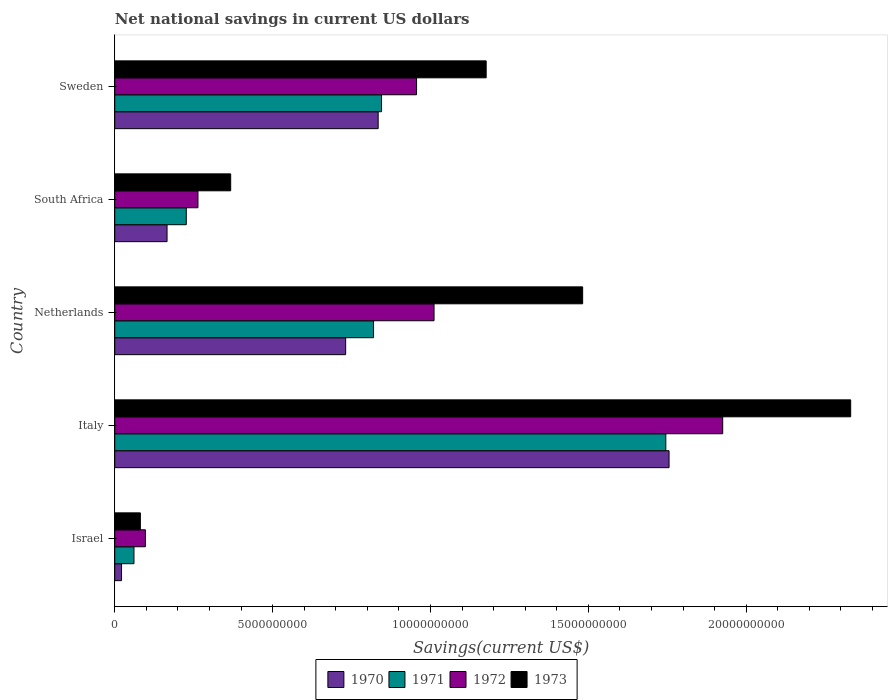How many different coloured bars are there?
Offer a terse response. 4. Are the number of bars on each tick of the Y-axis equal?
Provide a succinct answer. Yes. How many bars are there on the 5th tick from the top?
Ensure brevity in your answer.  4. How many bars are there on the 4th tick from the bottom?
Give a very brief answer. 4. What is the label of the 4th group of bars from the top?
Provide a short and direct response. Italy. What is the net national savings in 1970 in Italy?
Ensure brevity in your answer.  1.76e+1. Across all countries, what is the maximum net national savings in 1971?
Your answer should be compact. 1.75e+1. Across all countries, what is the minimum net national savings in 1970?
Ensure brevity in your answer.  2.15e+08. In which country was the net national savings in 1970 maximum?
Ensure brevity in your answer.  Italy. What is the total net national savings in 1970 in the graph?
Your response must be concise. 3.51e+1. What is the difference between the net national savings in 1973 in Netherlands and that in South Africa?
Your answer should be very brief. 1.11e+1. What is the difference between the net national savings in 1972 in Italy and the net national savings in 1973 in South Africa?
Offer a very short reply. 1.56e+1. What is the average net national savings in 1972 per country?
Your response must be concise. 8.51e+09. What is the difference between the net national savings in 1970 and net national savings in 1972 in Netherlands?
Offer a very short reply. -2.80e+09. What is the ratio of the net national savings in 1972 in Israel to that in Netherlands?
Make the answer very short. 0.1. Is the difference between the net national savings in 1970 in Italy and Sweden greater than the difference between the net national savings in 1972 in Italy and Sweden?
Provide a short and direct response. No. What is the difference between the highest and the second highest net national savings in 1972?
Keep it short and to the point. 9.14e+09. What is the difference between the highest and the lowest net national savings in 1972?
Give a very brief answer. 1.83e+1. In how many countries, is the net national savings in 1970 greater than the average net national savings in 1970 taken over all countries?
Provide a short and direct response. 3. Is the sum of the net national savings in 1971 in Israel and South Africa greater than the maximum net national savings in 1970 across all countries?
Offer a terse response. No. Is it the case that in every country, the sum of the net national savings in 1972 and net national savings in 1970 is greater than the sum of net national savings in 1973 and net national savings in 1971?
Your answer should be compact. No. What does the 2nd bar from the top in Italy represents?
Offer a very short reply. 1972. What is the difference between two consecutive major ticks on the X-axis?
Ensure brevity in your answer.  5.00e+09. Are the values on the major ticks of X-axis written in scientific E-notation?
Your response must be concise. No. Does the graph contain any zero values?
Your answer should be compact. No. Does the graph contain grids?
Ensure brevity in your answer.  No. Where does the legend appear in the graph?
Offer a terse response. Bottom center. What is the title of the graph?
Provide a succinct answer. Net national savings in current US dollars. What is the label or title of the X-axis?
Your response must be concise. Savings(current US$). What is the label or title of the Y-axis?
Make the answer very short. Country. What is the Savings(current US$) in 1970 in Israel?
Your answer should be compact. 2.15e+08. What is the Savings(current US$) in 1971 in Israel?
Ensure brevity in your answer.  6.09e+08. What is the Savings(current US$) in 1972 in Israel?
Your response must be concise. 9.71e+08. What is the Savings(current US$) in 1973 in Israel?
Your response must be concise. 8.11e+08. What is the Savings(current US$) of 1970 in Italy?
Offer a very short reply. 1.76e+1. What is the Savings(current US$) in 1971 in Italy?
Provide a succinct answer. 1.75e+1. What is the Savings(current US$) in 1972 in Italy?
Your answer should be compact. 1.93e+1. What is the Savings(current US$) in 1973 in Italy?
Give a very brief answer. 2.33e+1. What is the Savings(current US$) of 1970 in Netherlands?
Ensure brevity in your answer.  7.31e+09. What is the Savings(current US$) of 1971 in Netherlands?
Provide a succinct answer. 8.20e+09. What is the Savings(current US$) of 1972 in Netherlands?
Give a very brief answer. 1.01e+1. What is the Savings(current US$) in 1973 in Netherlands?
Make the answer very short. 1.48e+1. What is the Savings(current US$) in 1970 in South Africa?
Ensure brevity in your answer.  1.66e+09. What is the Savings(current US$) in 1971 in South Africa?
Offer a very short reply. 2.27e+09. What is the Savings(current US$) in 1972 in South Africa?
Give a very brief answer. 2.64e+09. What is the Savings(current US$) of 1973 in South Africa?
Offer a very short reply. 3.67e+09. What is the Savings(current US$) of 1970 in Sweden?
Offer a terse response. 8.34e+09. What is the Savings(current US$) in 1971 in Sweden?
Offer a very short reply. 8.45e+09. What is the Savings(current US$) of 1972 in Sweden?
Ensure brevity in your answer.  9.56e+09. What is the Savings(current US$) in 1973 in Sweden?
Give a very brief answer. 1.18e+1. Across all countries, what is the maximum Savings(current US$) in 1970?
Your response must be concise. 1.76e+1. Across all countries, what is the maximum Savings(current US$) in 1971?
Ensure brevity in your answer.  1.75e+1. Across all countries, what is the maximum Savings(current US$) in 1972?
Your answer should be compact. 1.93e+1. Across all countries, what is the maximum Savings(current US$) of 1973?
Ensure brevity in your answer.  2.33e+1. Across all countries, what is the minimum Savings(current US$) in 1970?
Offer a very short reply. 2.15e+08. Across all countries, what is the minimum Savings(current US$) of 1971?
Your answer should be compact. 6.09e+08. Across all countries, what is the minimum Savings(current US$) in 1972?
Give a very brief answer. 9.71e+08. Across all countries, what is the minimum Savings(current US$) of 1973?
Your answer should be very brief. 8.11e+08. What is the total Savings(current US$) in 1970 in the graph?
Your answer should be very brief. 3.51e+1. What is the total Savings(current US$) in 1971 in the graph?
Ensure brevity in your answer.  3.70e+1. What is the total Savings(current US$) of 1972 in the graph?
Keep it short and to the point. 4.25e+1. What is the total Savings(current US$) in 1973 in the graph?
Give a very brief answer. 5.44e+1. What is the difference between the Savings(current US$) in 1970 in Israel and that in Italy?
Offer a terse response. -1.73e+1. What is the difference between the Savings(current US$) in 1971 in Israel and that in Italy?
Your response must be concise. -1.68e+1. What is the difference between the Savings(current US$) in 1972 in Israel and that in Italy?
Keep it short and to the point. -1.83e+1. What is the difference between the Savings(current US$) of 1973 in Israel and that in Italy?
Give a very brief answer. -2.25e+1. What is the difference between the Savings(current US$) of 1970 in Israel and that in Netherlands?
Ensure brevity in your answer.  -7.10e+09. What is the difference between the Savings(current US$) in 1971 in Israel and that in Netherlands?
Ensure brevity in your answer.  -7.59e+09. What is the difference between the Savings(current US$) of 1972 in Israel and that in Netherlands?
Give a very brief answer. -9.14e+09. What is the difference between the Savings(current US$) of 1973 in Israel and that in Netherlands?
Keep it short and to the point. -1.40e+1. What is the difference between the Savings(current US$) of 1970 in Israel and that in South Africa?
Offer a terse response. -1.44e+09. What is the difference between the Savings(current US$) in 1971 in Israel and that in South Africa?
Offer a very short reply. -1.66e+09. What is the difference between the Savings(current US$) in 1972 in Israel and that in South Africa?
Your answer should be very brief. -1.66e+09. What is the difference between the Savings(current US$) of 1973 in Israel and that in South Africa?
Make the answer very short. -2.86e+09. What is the difference between the Savings(current US$) of 1970 in Israel and that in Sweden?
Offer a terse response. -8.13e+09. What is the difference between the Savings(current US$) of 1971 in Israel and that in Sweden?
Keep it short and to the point. -7.84e+09. What is the difference between the Savings(current US$) in 1972 in Israel and that in Sweden?
Offer a terse response. -8.59e+09. What is the difference between the Savings(current US$) of 1973 in Israel and that in Sweden?
Provide a succinct answer. -1.10e+1. What is the difference between the Savings(current US$) in 1970 in Italy and that in Netherlands?
Offer a very short reply. 1.02e+1. What is the difference between the Savings(current US$) of 1971 in Italy and that in Netherlands?
Offer a terse response. 9.26e+09. What is the difference between the Savings(current US$) in 1972 in Italy and that in Netherlands?
Your answer should be compact. 9.14e+09. What is the difference between the Savings(current US$) of 1973 in Italy and that in Netherlands?
Your answer should be compact. 8.49e+09. What is the difference between the Savings(current US$) of 1970 in Italy and that in South Africa?
Your response must be concise. 1.59e+1. What is the difference between the Savings(current US$) of 1971 in Italy and that in South Africa?
Keep it short and to the point. 1.52e+1. What is the difference between the Savings(current US$) of 1972 in Italy and that in South Africa?
Offer a terse response. 1.66e+1. What is the difference between the Savings(current US$) of 1973 in Italy and that in South Africa?
Offer a terse response. 1.96e+1. What is the difference between the Savings(current US$) in 1970 in Italy and that in Sweden?
Make the answer very short. 9.21e+09. What is the difference between the Savings(current US$) in 1971 in Italy and that in Sweden?
Ensure brevity in your answer.  9.00e+09. What is the difference between the Savings(current US$) in 1972 in Italy and that in Sweden?
Keep it short and to the point. 9.70e+09. What is the difference between the Savings(current US$) of 1973 in Italy and that in Sweden?
Your answer should be very brief. 1.15e+1. What is the difference between the Savings(current US$) of 1970 in Netherlands and that in South Africa?
Give a very brief answer. 5.66e+09. What is the difference between the Savings(current US$) in 1971 in Netherlands and that in South Africa?
Offer a terse response. 5.93e+09. What is the difference between the Savings(current US$) in 1972 in Netherlands and that in South Africa?
Provide a short and direct response. 7.48e+09. What is the difference between the Savings(current US$) of 1973 in Netherlands and that in South Africa?
Provide a short and direct response. 1.11e+1. What is the difference between the Savings(current US$) of 1970 in Netherlands and that in Sweden?
Provide a succinct answer. -1.03e+09. What is the difference between the Savings(current US$) of 1971 in Netherlands and that in Sweden?
Ensure brevity in your answer.  -2.53e+08. What is the difference between the Savings(current US$) of 1972 in Netherlands and that in Sweden?
Your answer should be very brief. 5.54e+08. What is the difference between the Savings(current US$) of 1973 in Netherlands and that in Sweden?
Make the answer very short. 3.06e+09. What is the difference between the Savings(current US$) in 1970 in South Africa and that in Sweden?
Provide a short and direct response. -6.69e+09. What is the difference between the Savings(current US$) in 1971 in South Africa and that in Sweden?
Your answer should be very brief. -6.18e+09. What is the difference between the Savings(current US$) of 1972 in South Africa and that in Sweden?
Your answer should be very brief. -6.92e+09. What is the difference between the Savings(current US$) in 1973 in South Africa and that in Sweden?
Ensure brevity in your answer.  -8.09e+09. What is the difference between the Savings(current US$) of 1970 in Israel and the Savings(current US$) of 1971 in Italy?
Offer a terse response. -1.72e+1. What is the difference between the Savings(current US$) of 1970 in Israel and the Savings(current US$) of 1972 in Italy?
Provide a short and direct response. -1.90e+1. What is the difference between the Savings(current US$) of 1970 in Israel and the Savings(current US$) of 1973 in Italy?
Make the answer very short. -2.31e+1. What is the difference between the Savings(current US$) in 1971 in Israel and the Savings(current US$) in 1972 in Italy?
Make the answer very short. -1.86e+1. What is the difference between the Savings(current US$) in 1971 in Israel and the Savings(current US$) in 1973 in Italy?
Make the answer very short. -2.27e+1. What is the difference between the Savings(current US$) in 1972 in Israel and the Savings(current US$) in 1973 in Italy?
Your answer should be very brief. -2.23e+1. What is the difference between the Savings(current US$) of 1970 in Israel and the Savings(current US$) of 1971 in Netherlands?
Your response must be concise. -7.98e+09. What is the difference between the Savings(current US$) in 1970 in Israel and the Savings(current US$) in 1972 in Netherlands?
Provide a short and direct response. -9.90e+09. What is the difference between the Savings(current US$) in 1970 in Israel and the Savings(current US$) in 1973 in Netherlands?
Offer a very short reply. -1.46e+1. What is the difference between the Savings(current US$) of 1971 in Israel and the Savings(current US$) of 1972 in Netherlands?
Provide a succinct answer. -9.50e+09. What is the difference between the Savings(current US$) in 1971 in Israel and the Savings(current US$) in 1973 in Netherlands?
Provide a succinct answer. -1.42e+1. What is the difference between the Savings(current US$) in 1972 in Israel and the Savings(current US$) in 1973 in Netherlands?
Your answer should be compact. -1.38e+1. What is the difference between the Savings(current US$) of 1970 in Israel and the Savings(current US$) of 1971 in South Africa?
Keep it short and to the point. -2.05e+09. What is the difference between the Savings(current US$) of 1970 in Israel and the Savings(current US$) of 1972 in South Africa?
Your response must be concise. -2.42e+09. What is the difference between the Savings(current US$) of 1970 in Israel and the Savings(current US$) of 1973 in South Africa?
Your answer should be very brief. -3.46e+09. What is the difference between the Savings(current US$) of 1971 in Israel and the Savings(current US$) of 1972 in South Africa?
Ensure brevity in your answer.  -2.03e+09. What is the difference between the Savings(current US$) of 1971 in Israel and the Savings(current US$) of 1973 in South Africa?
Make the answer very short. -3.06e+09. What is the difference between the Savings(current US$) of 1972 in Israel and the Savings(current US$) of 1973 in South Africa?
Offer a terse response. -2.70e+09. What is the difference between the Savings(current US$) in 1970 in Israel and the Savings(current US$) in 1971 in Sweden?
Offer a terse response. -8.23e+09. What is the difference between the Savings(current US$) in 1970 in Israel and the Savings(current US$) in 1972 in Sweden?
Your response must be concise. -9.34e+09. What is the difference between the Savings(current US$) of 1970 in Israel and the Savings(current US$) of 1973 in Sweden?
Give a very brief answer. -1.15e+1. What is the difference between the Savings(current US$) of 1971 in Israel and the Savings(current US$) of 1972 in Sweden?
Provide a succinct answer. -8.95e+09. What is the difference between the Savings(current US$) of 1971 in Israel and the Savings(current US$) of 1973 in Sweden?
Offer a very short reply. -1.12e+1. What is the difference between the Savings(current US$) in 1972 in Israel and the Savings(current US$) in 1973 in Sweden?
Keep it short and to the point. -1.08e+1. What is the difference between the Savings(current US$) in 1970 in Italy and the Savings(current US$) in 1971 in Netherlands?
Offer a very short reply. 9.36e+09. What is the difference between the Savings(current US$) in 1970 in Italy and the Savings(current US$) in 1972 in Netherlands?
Ensure brevity in your answer.  7.44e+09. What is the difference between the Savings(current US$) in 1970 in Italy and the Savings(current US$) in 1973 in Netherlands?
Your response must be concise. 2.74e+09. What is the difference between the Savings(current US$) in 1971 in Italy and the Savings(current US$) in 1972 in Netherlands?
Provide a short and direct response. 7.34e+09. What is the difference between the Savings(current US$) in 1971 in Italy and the Savings(current US$) in 1973 in Netherlands?
Offer a terse response. 2.63e+09. What is the difference between the Savings(current US$) of 1972 in Italy and the Savings(current US$) of 1973 in Netherlands?
Provide a short and direct response. 4.44e+09. What is the difference between the Savings(current US$) in 1970 in Italy and the Savings(current US$) in 1971 in South Africa?
Keep it short and to the point. 1.53e+1. What is the difference between the Savings(current US$) of 1970 in Italy and the Savings(current US$) of 1972 in South Africa?
Give a very brief answer. 1.49e+1. What is the difference between the Savings(current US$) in 1970 in Italy and the Savings(current US$) in 1973 in South Africa?
Make the answer very short. 1.39e+1. What is the difference between the Savings(current US$) in 1971 in Italy and the Savings(current US$) in 1972 in South Africa?
Ensure brevity in your answer.  1.48e+1. What is the difference between the Savings(current US$) in 1971 in Italy and the Savings(current US$) in 1973 in South Africa?
Offer a very short reply. 1.38e+1. What is the difference between the Savings(current US$) of 1972 in Italy and the Savings(current US$) of 1973 in South Africa?
Your answer should be very brief. 1.56e+1. What is the difference between the Savings(current US$) of 1970 in Italy and the Savings(current US$) of 1971 in Sweden?
Ensure brevity in your answer.  9.11e+09. What is the difference between the Savings(current US$) of 1970 in Italy and the Savings(current US$) of 1972 in Sweden?
Offer a very short reply. 8.00e+09. What is the difference between the Savings(current US$) of 1970 in Italy and the Savings(current US$) of 1973 in Sweden?
Give a very brief answer. 5.79e+09. What is the difference between the Savings(current US$) of 1971 in Italy and the Savings(current US$) of 1972 in Sweden?
Give a very brief answer. 7.89e+09. What is the difference between the Savings(current US$) in 1971 in Italy and the Savings(current US$) in 1973 in Sweden?
Your response must be concise. 5.69e+09. What is the difference between the Savings(current US$) of 1972 in Italy and the Savings(current US$) of 1973 in Sweden?
Offer a very short reply. 7.49e+09. What is the difference between the Savings(current US$) of 1970 in Netherlands and the Savings(current US$) of 1971 in South Africa?
Your response must be concise. 5.05e+09. What is the difference between the Savings(current US$) of 1970 in Netherlands and the Savings(current US$) of 1972 in South Africa?
Offer a terse response. 4.68e+09. What is the difference between the Savings(current US$) of 1970 in Netherlands and the Savings(current US$) of 1973 in South Africa?
Your response must be concise. 3.64e+09. What is the difference between the Savings(current US$) of 1971 in Netherlands and the Savings(current US$) of 1972 in South Africa?
Your answer should be very brief. 5.56e+09. What is the difference between the Savings(current US$) of 1971 in Netherlands and the Savings(current US$) of 1973 in South Africa?
Ensure brevity in your answer.  4.52e+09. What is the difference between the Savings(current US$) in 1972 in Netherlands and the Savings(current US$) in 1973 in South Africa?
Offer a terse response. 6.44e+09. What is the difference between the Savings(current US$) of 1970 in Netherlands and the Savings(current US$) of 1971 in Sweden?
Offer a very short reply. -1.14e+09. What is the difference between the Savings(current US$) of 1970 in Netherlands and the Savings(current US$) of 1972 in Sweden?
Make the answer very short. -2.25e+09. What is the difference between the Savings(current US$) in 1970 in Netherlands and the Savings(current US$) in 1973 in Sweden?
Your response must be concise. -4.45e+09. What is the difference between the Savings(current US$) in 1971 in Netherlands and the Savings(current US$) in 1972 in Sweden?
Ensure brevity in your answer.  -1.36e+09. What is the difference between the Savings(current US$) of 1971 in Netherlands and the Savings(current US$) of 1973 in Sweden?
Your answer should be compact. -3.57e+09. What is the difference between the Savings(current US$) of 1972 in Netherlands and the Savings(current US$) of 1973 in Sweden?
Your response must be concise. -1.65e+09. What is the difference between the Savings(current US$) of 1970 in South Africa and the Savings(current US$) of 1971 in Sweden?
Your answer should be compact. -6.79e+09. What is the difference between the Savings(current US$) in 1970 in South Africa and the Savings(current US$) in 1972 in Sweden?
Make the answer very short. -7.90e+09. What is the difference between the Savings(current US$) in 1970 in South Africa and the Savings(current US$) in 1973 in Sweden?
Provide a short and direct response. -1.01e+1. What is the difference between the Savings(current US$) of 1971 in South Africa and the Savings(current US$) of 1972 in Sweden?
Give a very brief answer. -7.29e+09. What is the difference between the Savings(current US$) in 1971 in South Africa and the Savings(current US$) in 1973 in Sweden?
Ensure brevity in your answer.  -9.50e+09. What is the difference between the Savings(current US$) in 1972 in South Africa and the Savings(current US$) in 1973 in Sweden?
Your response must be concise. -9.13e+09. What is the average Savings(current US$) of 1970 per country?
Your response must be concise. 7.02e+09. What is the average Savings(current US$) of 1971 per country?
Provide a short and direct response. 7.39e+09. What is the average Savings(current US$) in 1972 per country?
Your answer should be very brief. 8.51e+09. What is the average Savings(current US$) in 1973 per country?
Ensure brevity in your answer.  1.09e+1. What is the difference between the Savings(current US$) in 1970 and Savings(current US$) in 1971 in Israel?
Offer a terse response. -3.94e+08. What is the difference between the Savings(current US$) of 1970 and Savings(current US$) of 1972 in Israel?
Offer a terse response. -7.56e+08. What is the difference between the Savings(current US$) in 1970 and Savings(current US$) in 1973 in Israel?
Your answer should be very brief. -5.96e+08. What is the difference between the Savings(current US$) in 1971 and Savings(current US$) in 1972 in Israel?
Make the answer very short. -3.62e+08. What is the difference between the Savings(current US$) in 1971 and Savings(current US$) in 1973 in Israel?
Make the answer very short. -2.02e+08. What is the difference between the Savings(current US$) in 1972 and Savings(current US$) in 1973 in Israel?
Offer a very short reply. 1.60e+08. What is the difference between the Savings(current US$) of 1970 and Savings(current US$) of 1971 in Italy?
Your answer should be compact. 1.03e+08. What is the difference between the Savings(current US$) of 1970 and Savings(current US$) of 1972 in Italy?
Your answer should be compact. -1.70e+09. What is the difference between the Savings(current US$) in 1970 and Savings(current US$) in 1973 in Italy?
Your response must be concise. -5.75e+09. What is the difference between the Savings(current US$) in 1971 and Savings(current US$) in 1972 in Italy?
Your response must be concise. -1.80e+09. What is the difference between the Savings(current US$) of 1971 and Savings(current US$) of 1973 in Italy?
Your answer should be very brief. -5.86e+09. What is the difference between the Savings(current US$) in 1972 and Savings(current US$) in 1973 in Italy?
Give a very brief answer. -4.05e+09. What is the difference between the Savings(current US$) in 1970 and Savings(current US$) in 1971 in Netherlands?
Offer a very short reply. -8.83e+08. What is the difference between the Savings(current US$) of 1970 and Savings(current US$) of 1972 in Netherlands?
Your response must be concise. -2.80e+09. What is the difference between the Savings(current US$) in 1970 and Savings(current US$) in 1973 in Netherlands?
Your answer should be very brief. -7.51e+09. What is the difference between the Savings(current US$) of 1971 and Savings(current US$) of 1972 in Netherlands?
Make the answer very short. -1.92e+09. What is the difference between the Savings(current US$) of 1971 and Savings(current US$) of 1973 in Netherlands?
Provide a succinct answer. -6.62e+09. What is the difference between the Savings(current US$) of 1972 and Savings(current US$) of 1973 in Netherlands?
Your answer should be compact. -4.71e+09. What is the difference between the Savings(current US$) in 1970 and Savings(current US$) in 1971 in South Africa?
Your answer should be very brief. -6.09e+08. What is the difference between the Savings(current US$) in 1970 and Savings(current US$) in 1972 in South Africa?
Your answer should be very brief. -9.79e+08. What is the difference between the Savings(current US$) in 1970 and Savings(current US$) in 1973 in South Africa?
Offer a terse response. -2.02e+09. What is the difference between the Savings(current US$) of 1971 and Savings(current US$) of 1972 in South Africa?
Provide a short and direct response. -3.70e+08. What is the difference between the Savings(current US$) of 1971 and Savings(current US$) of 1973 in South Africa?
Keep it short and to the point. -1.41e+09. What is the difference between the Savings(current US$) of 1972 and Savings(current US$) of 1973 in South Africa?
Your response must be concise. -1.04e+09. What is the difference between the Savings(current US$) of 1970 and Savings(current US$) of 1971 in Sweden?
Offer a very short reply. -1.07e+08. What is the difference between the Savings(current US$) in 1970 and Savings(current US$) in 1972 in Sweden?
Provide a short and direct response. -1.22e+09. What is the difference between the Savings(current US$) in 1970 and Savings(current US$) in 1973 in Sweden?
Provide a succinct answer. -3.42e+09. What is the difference between the Savings(current US$) of 1971 and Savings(current US$) of 1972 in Sweden?
Provide a succinct answer. -1.11e+09. What is the difference between the Savings(current US$) of 1971 and Savings(current US$) of 1973 in Sweden?
Provide a succinct answer. -3.31e+09. What is the difference between the Savings(current US$) of 1972 and Savings(current US$) of 1973 in Sweden?
Offer a very short reply. -2.20e+09. What is the ratio of the Savings(current US$) in 1970 in Israel to that in Italy?
Make the answer very short. 0.01. What is the ratio of the Savings(current US$) in 1971 in Israel to that in Italy?
Keep it short and to the point. 0.03. What is the ratio of the Savings(current US$) in 1972 in Israel to that in Italy?
Offer a terse response. 0.05. What is the ratio of the Savings(current US$) of 1973 in Israel to that in Italy?
Offer a terse response. 0.03. What is the ratio of the Savings(current US$) in 1970 in Israel to that in Netherlands?
Make the answer very short. 0.03. What is the ratio of the Savings(current US$) of 1971 in Israel to that in Netherlands?
Provide a succinct answer. 0.07. What is the ratio of the Savings(current US$) of 1972 in Israel to that in Netherlands?
Your answer should be compact. 0.1. What is the ratio of the Savings(current US$) in 1973 in Israel to that in Netherlands?
Offer a very short reply. 0.05. What is the ratio of the Savings(current US$) in 1970 in Israel to that in South Africa?
Provide a succinct answer. 0.13. What is the ratio of the Savings(current US$) of 1971 in Israel to that in South Africa?
Your answer should be compact. 0.27. What is the ratio of the Savings(current US$) in 1972 in Israel to that in South Africa?
Give a very brief answer. 0.37. What is the ratio of the Savings(current US$) in 1973 in Israel to that in South Africa?
Offer a terse response. 0.22. What is the ratio of the Savings(current US$) of 1970 in Israel to that in Sweden?
Your answer should be compact. 0.03. What is the ratio of the Savings(current US$) of 1971 in Israel to that in Sweden?
Make the answer very short. 0.07. What is the ratio of the Savings(current US$) of 1972 in Israel to that in Sweden?
Provide a short and direct response. 0.1. What is the ratio of the Savings(current US$) in 1973 in Israel to that in Sweden?
Your response must be concise. 0.07. What is the ratio of the Savings(current US$) in 1970 in Italy to that in Netherlands?
Offer a very short reply. 2.4. What is the ratio of the Savings(current US$) of 1971 in Italy to that in Netherlands?
Ensure brevity in your answer.  2.13. What is the ratio of the Savings(current US$) in 1972 in Italy to that in Netherlands?
Offer a terse response. 1.9. What is the ratio of the Savings(current US$) in 1973 in Italy to that in Netherlands?
Offer a terse response. 1.57. What is the ratio of the Savings(current US$) in 1970 in Italy to that in South Africa?
Offer a very short reply. 10.6. What is the ratio of the Savings(current US$) in 1971 in Italy to that in South Africa?
Ensure brevity in your answer.  7.7. What is the ratio of the Savings(current US$) of 1972 in Italy to that in South Africa?
Offer a very short reply. 7.31. What is the ratio of the Savings(current US$) of 1973 in Italy to that in South Africa?
Offer a terse response. 6.35. What is the ratio of the Savings(current US$) of 1970 in Italy to that in Sweden?
Your response must be concise. 2.1. What is the ratio of the Savings(current US$) in 1971 in Italy to that in Sweden?
Offer a very short reply. 2.07. What is the ratio of the Savings(current US$) of 1972 in Italy to that in Sweden?
Offer a terse response. 2.01. What is the ratio of the Savings(current US$) of 1973 in Italy to that in Sweden?
Make the answer very short. 1.98. What is the ratio of the Savings(current US$) of 1970 in Netherlands to that in South Africa?
Ensure brevity in your answer.  4.42. What is the ratio of the Savings(current US$) of 1971 in Netherlands to that in South Africa?
Provide a short and direct response. 3.62. What is the ratio of the Savings(current US$) of 1972 in Netherlands to that in South Africa?
Offer a very short reply. 3.84. What is the ratio of the Savings(current US$) in 1973 in Netherlands to that in South Africa?
Ensure brevity in your answer.  4.04. What is the ratio of the Savings(current US$) of 1970 in Netherlands to that in Sweden?
Ensure brevity in your answer.  0.88. What is the ratio of the Savings(current US$) of 1971 in Netherlands to that in Sweden?
Your response must be concise. 0.97. What is the ratio of the Savings(current US$) in 1972 in Netherlands to that in Sweden?
Provide a short and direct response. 1.06. What is the ratio of the Savings(current US$) of 1973 in Netherlands to that in Sweden?
Offer a terse response. 1.26. What is the ratio of the Savings(current US$) of 1970 in South Africa to that in Sweden?
Your answer should be compact. 0.2. What is the ratio of the Savings(current US$) in 1971 in South Africa to that in Sweden?
Provide a succinct answer. 0.27. What is the ratio of the Savings(current US$) in 1972 in South Africa to that in Sweden?
Give a very brief answer. 0.28. What is the ratio of the Savings(current US$) in 1973 in South Africa to that in Sweden?
Keep it short and to the point. 0.31. What is the difference between the highest and the second highest Savings(current US$) in 1970?
Give a very brief answer. 9.21e+09. What is the difference between the highest and the second highest Savings(current US$) in 1971?
Provide a short and direct response. 9.00e+09. What is the difference between the highest and the second highest Savings(current US$) in 1972?
Offer a very short reply. 9.14e+09. What is the difference between the highest and the second highest Savings(current US$) in 1973?
Keep it short and to the point. 8.49e+09. What is the difference between the highest and the lowest Savings(current US$) of 1970?
Your answer should be compact. 1.73e+1. What is the difference between the highest and the lowest Savings(current US$) of 1971?
Offer a terse response. 1.68e+1. What is the difference between the highest and the lowest Savings(current US$) in 1972?
Offer a terse response. 1.83e+1. What is the difference between the highest and the lowest Savings(current US$) in 1973?
Your answer should be very brief. 2.25e+1. 